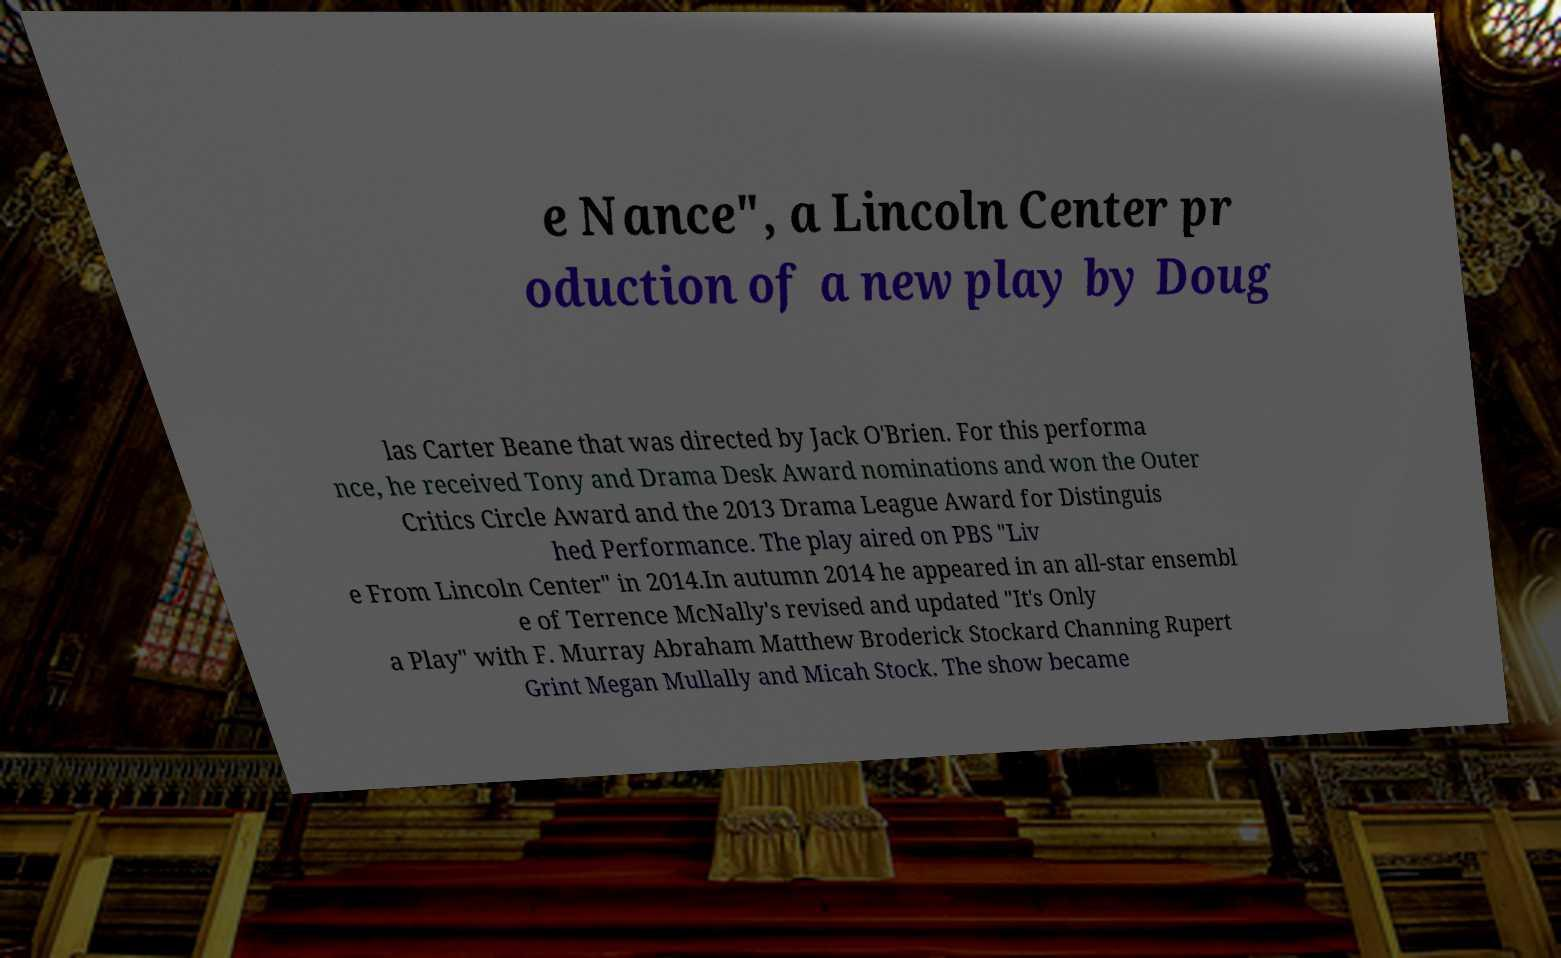For documentation purposes, I need the text within this image transcribed. Could you provide that? e Nance", a Lincoln Center pr oduction of a new play by Doug las Carter Beane that was directed by Jack O'Brien. For this performa nce, he received Tony and Drama Desk Award nominations and won the Outer Critics Circle Award and the 2013 Drama League Award for Distinguis hed Performance. The play aired on PBS "Liv e From Lincoln Center" in 2014.In autumn 2014 he appeared in an all-star ensembl e of Terrence McNally's revised and updated "It's Only a Play" with F. Murray Abraham Matthew Broderick Stockard Channing Rupert Grint Megan Mullally and Micah Stock. The show became 